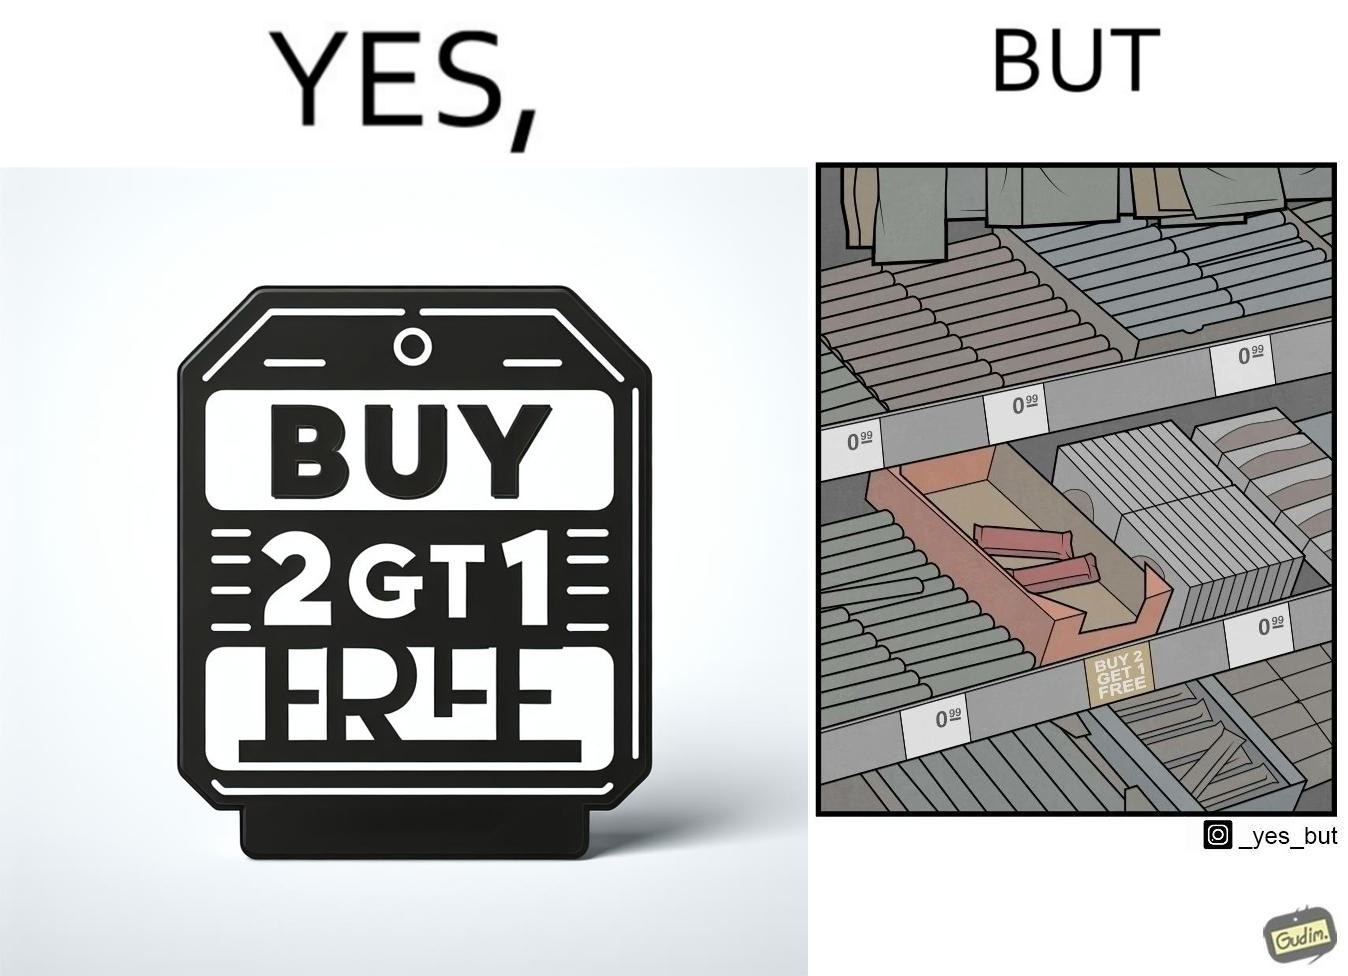Why is this image considered satirical? The image is funny because while there is an offer that lets the buyer have a free item if they buy two items of the product, there is only two units left which means that the buyer won't get the free unit. 